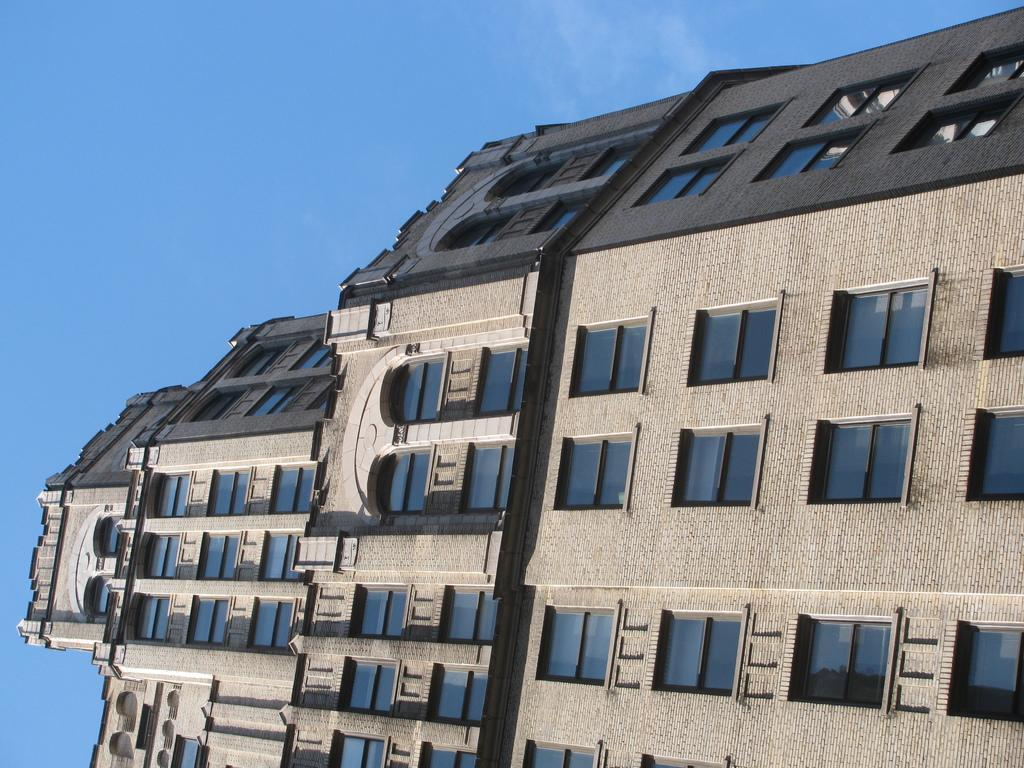What structure is present in the image? There is a building in the image. What feature can be seen on the building? There are windows visible in the image. What can be seen in the background of the image? The sky is visible in the background of the image. How many dinosaurs can be seen on the roof of the building in the image? There are no dinosaurs present on the roof of the building in the image. What type of fang is visible on the windows of the building? There are no fangs visible on the windows of the building in the image. 